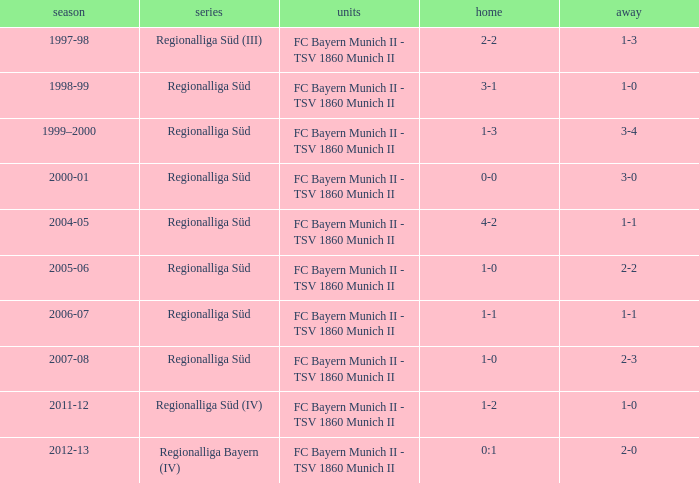Which season has the regionalliga süd (iii) league? 1997-98. 